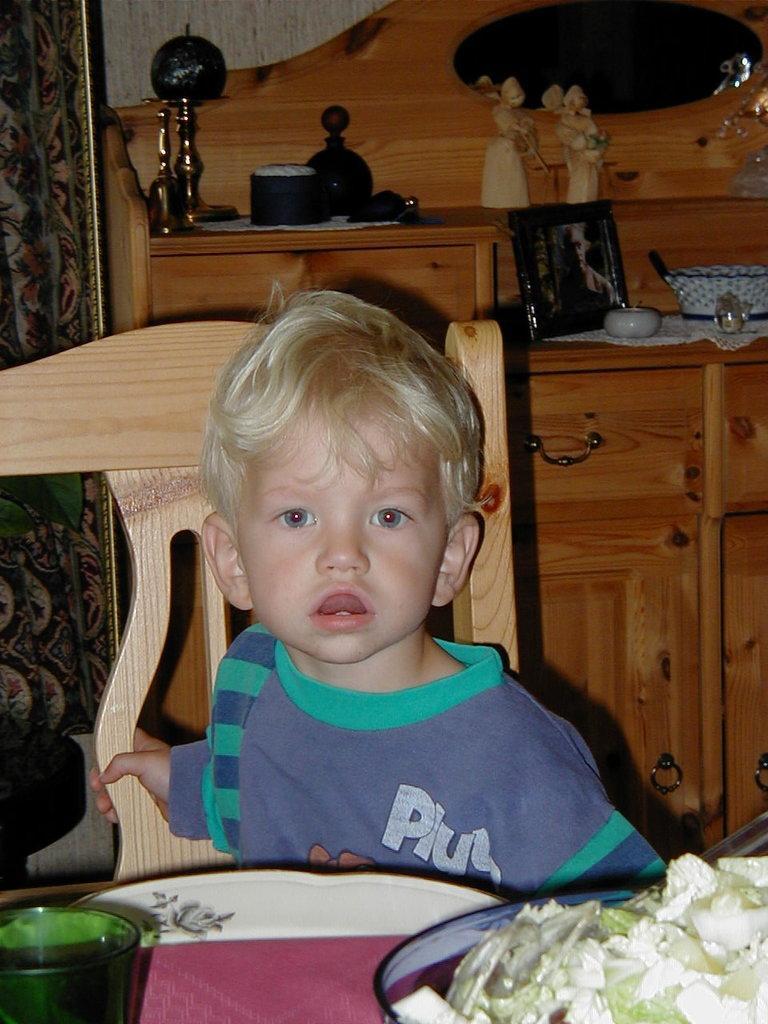Could you give a brief overview of what you see in this image? In this image there is a boy sitting in the chair. In front of him there is a table on which there is a glass and a plate full of food. In the background there are cupboards on which there are frames,toys,bowls on it. On the left side there is a curtain. 